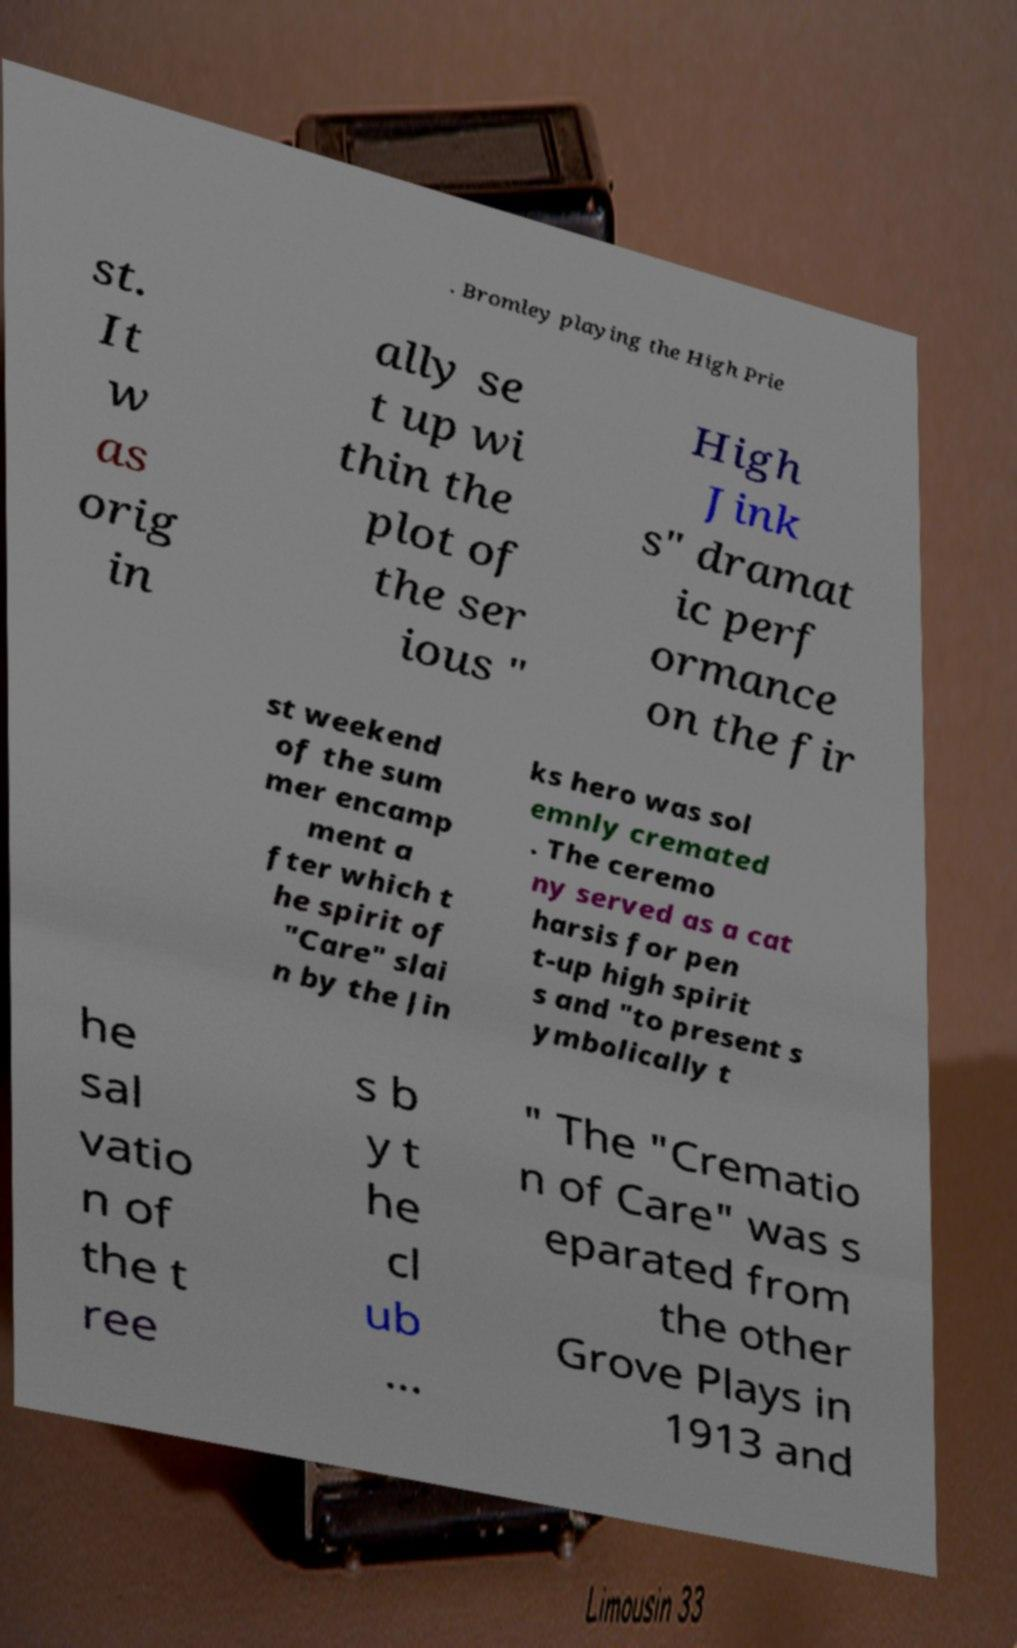There's text embedded in this image that I need extracted. Can you transcribe it verbatim? . Bromley playing the High Prie st. It w as orig in ally se t up wi thin the plot of the ser ious " High Jink s" dramat ic perf ormance on the fir st weekend of the sum mer encamp ment a fter which t he spirit of "Care" slai n by the Jin ks hero was sol emnly cremated . The ceremo ny served as a cat harsis for pen t-up high spirit s and "to present s ymbolically t he sal vatio n of the t ree s b y t he cl ub ... " The "Crematio n of Care" was s eparated from the other Grove Plays in 1913 and 